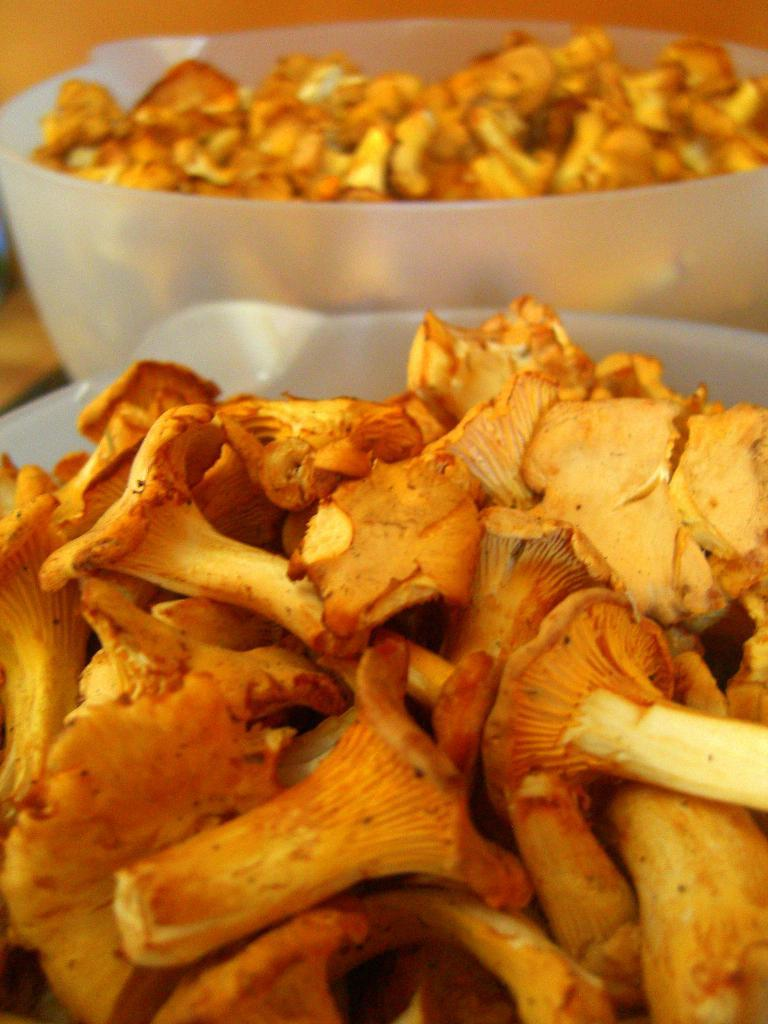What type of containers are present in the image? There are plastic containers in the image. What color are the plastic containers? The plastic containers are white in color. What is inside the containers? There are mushrooms in the containers. What colors can be seen on the mushrooms? The mushrooms are cream, brown, and orange in color. How many vegetables are in the fifth container? There is no fifth container present in the image, and the containers hold mushrooms, not vegetables. 